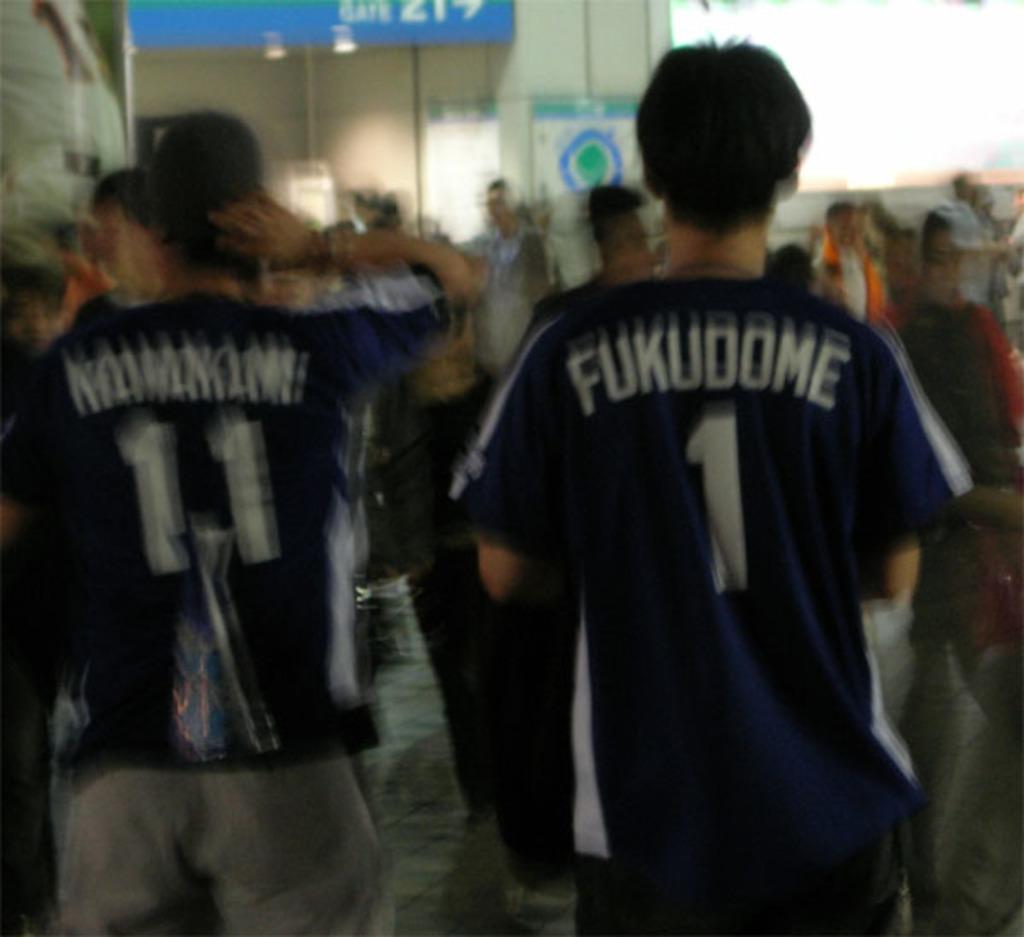What is the name of player #1?
Your answer should be very brief. Fukudome. 